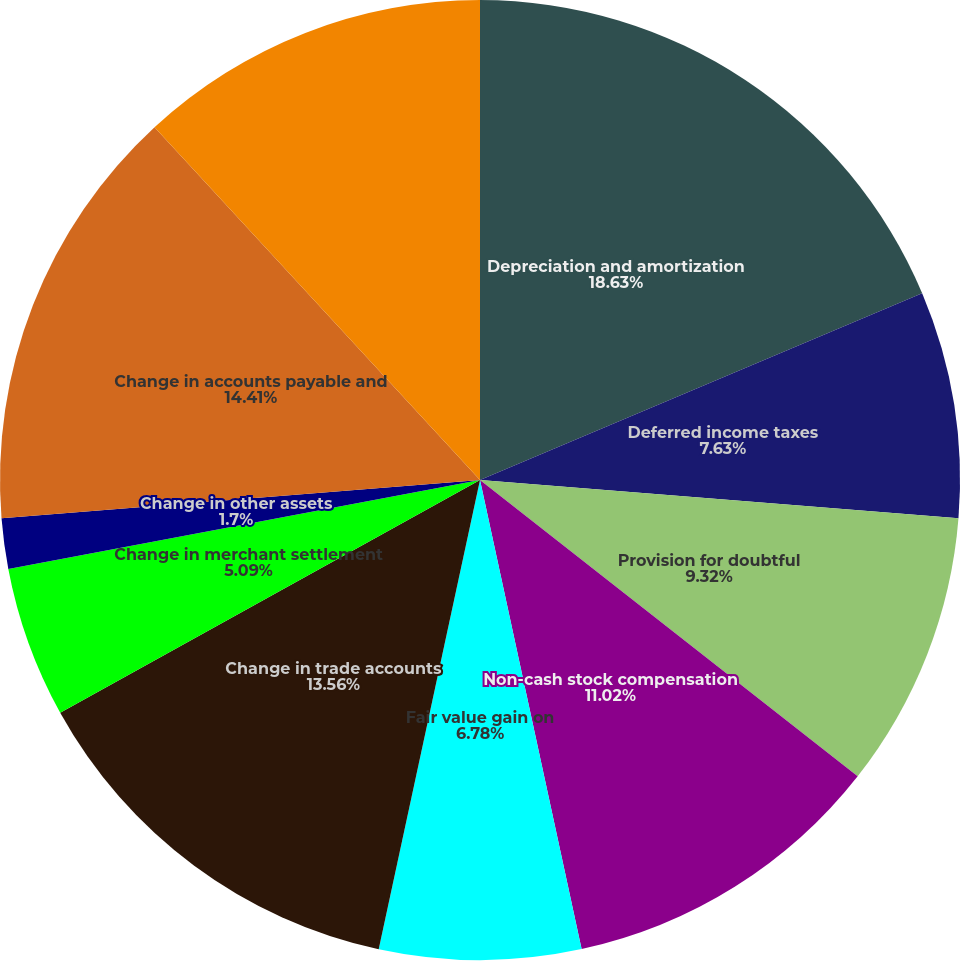Convert chart. <chart><loc_0><loc_0><loc_500><loc_500><pie_chart><fcel>Depreciation and amortization<fcel>Deferred income taxes<fcel>Provision for doubtful<fcel>Non-cash stock compensation<fcel>Fair value gain on<fcel>Change in trade accounts<fcel>Change in merchant settlement<fcel>Change in other assets<fcel>Change in accounts payable and<fcel>Change in deferred revenue<nl><fcel>18.64%<fcel>7.63%<fcel>9.32%<fcel>11.02%<fcel>6.78%<fcel>13.56%<fcel>5.09%<fcel>1.7%<fcel>14.41%<fcel>11.86%<nl></chart> 